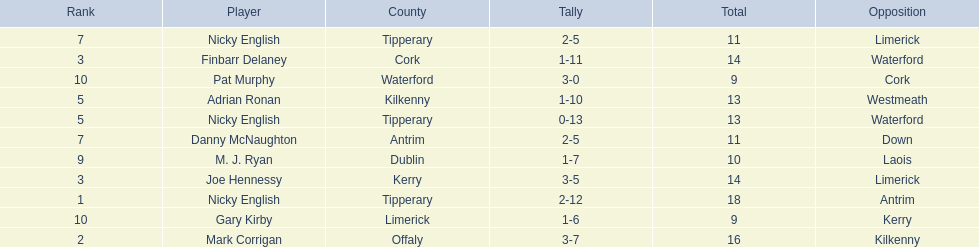Who are all the players? Nicky English, Mark Corrigan, Joe Hennessy, Finbarr Delaney, Nicky English, Adrian Ronan, Nicky English, Danny McNaughton, M. J. Ryan, Gary Kirby, Pat Murphy. How many points did they receive? 18, 16, 14, 14, 13, 13, 11, 11, 10, 9, 9. And which player received 10 points? M. J. Ryan. 